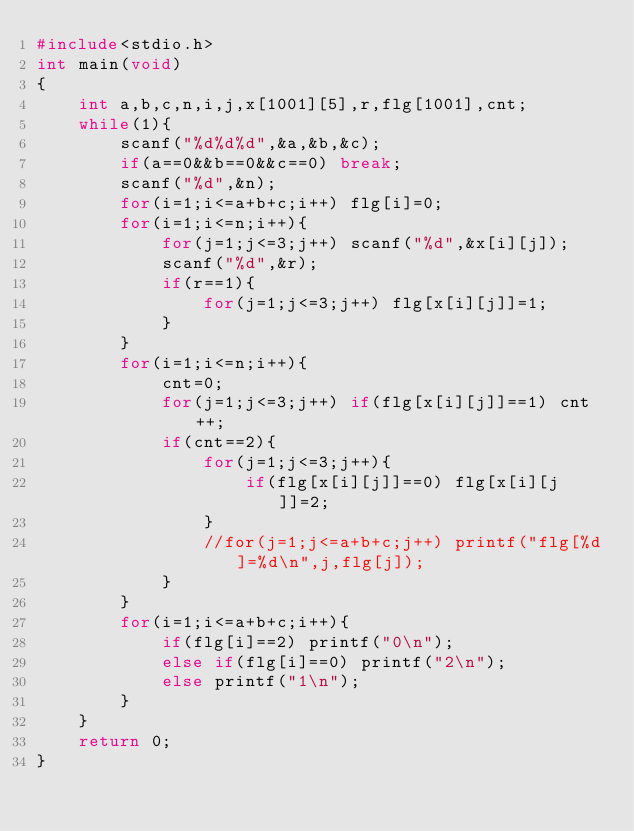Convert code to text. <code><loc_0><loc_0><loc_500><loc_500><_C_>#include<stdio.h>
int main(void)
{
	int a,b,c,n,i,j,x[1001][5],r,flg[1001],cnt;
	while(1){
		scanf("%d%d%d",&a,&b,&c);
		if(a==0&&b==0&&c==0) break;
		scanf("%d",&n);
		for(i=1;i<=a+b+c;i++) flg[i]=0; 
		for(i=1;i<=n;i++){
			for(j=1;j<=3;j++) scanf("%d",&x[i][j]);
			scanf("%d",&r);
			if(r==1){
				for(j=1;j<=3;j++) flg[x[i][j]]=1;
			}
		}
		for(i=1;i<=n;i++){
			cnt=0;
			for(j=1;j<=3;j++) if(flg[x[i][j]]==1) cnt++;
			if(cnt==2){
				for(j=1;j<=3;j++){
					if(flg[x[i][j]]==0) flg[x[i][j]]=2;
				}
				//for(j=1;j<=a+b+c;j++) printf("flg[%d]=%d\n",j,flg[j]);
			}
		}
		for(i=1;i<=a+b+c;i++){
			if(flg[i]==2) printf("0\n");
			else if(flg[i]==0) printf("2\n");
			else printf("1\n");
		}
	}
	return 0;
}</code> 